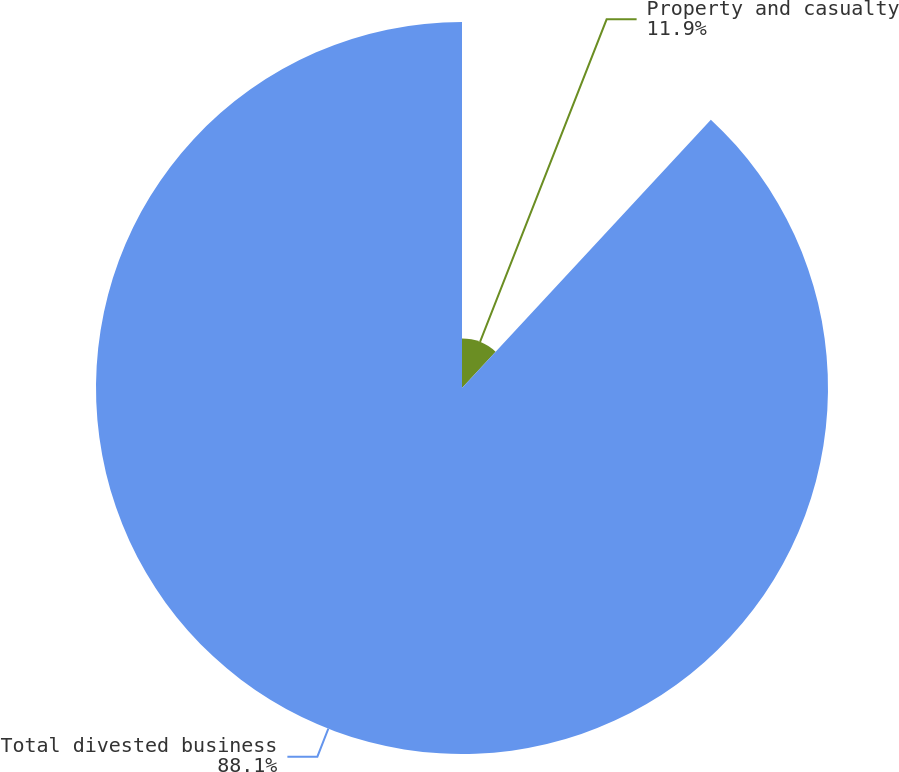<chart> <loc_0><loc_0><loc_500><loc_500><pie_chart><fcel>Property and casualty<fcel>Total divested business<nl><fcel>11.9%<fcel>88.1%<nl></chart> 